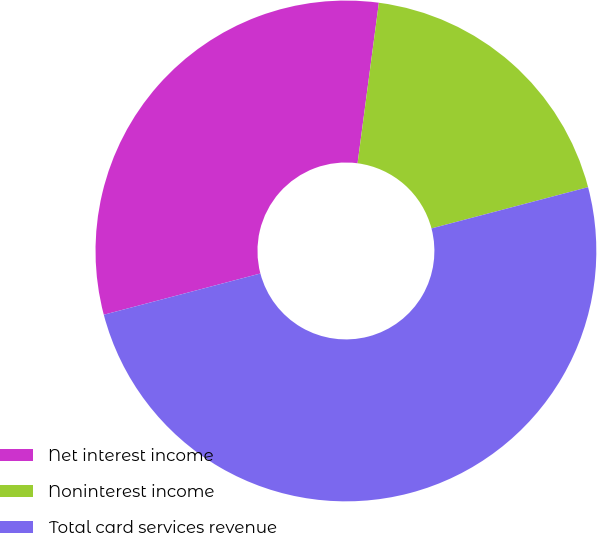<chart> <loc_0><loc_0><loc_500><loc_500><pie_chart><fcel>Net interest income<fcel>Noninterest income<fcel>Total card services revenue<nl><fcel>31.2%<fcel>18.8%<fcel>50.0%<nl></chart> 